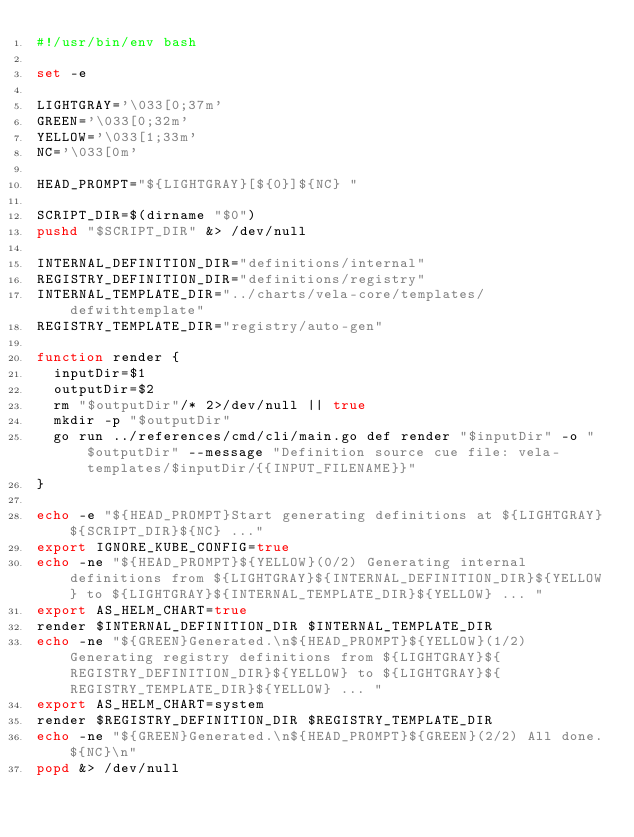Convert code to text. <code><loc_0><loc_0><loc_500><loc_500><_Bash_>#!/usr/bin/env bash

set -e

LIGHTGRAY='\033[0;37m'
GREEN='\033[0;32m'
YELLOW='\033[1;33m'
NC='\033[0m'

HEAD_PROMPT="${LIGHTGRAY}[${0}]${NC} "

SCRIPT_DIR=$(dirname "$0")
pushd "$SCRIPT_DIR" &> /dev/null

INTERNAL_DEFINITION_DIR="definitions/internal"
REGISTRY_DEFINITION_DIR="definitions/registry"
INTERNAL_TEMPLATE_DIR="../charts/vela-core/templates/defwithtemplate"
REGISTRY_TEMPLATE_DIR="registry/auto-gen"

function render {
  inputDir=$1
  outputDir=$2
  rm "$outputDir"/* 2>/dev/null || true
  mkdir -p "$outputDir"
  go run ../references/cmd/cli/main.go def render "$inputDir" -o "$outputDir" --message "Definition source cue file: vela-templates/$inputDir/{{INPUT_FILENAME}}"
}

echo -e "${HEAD_PROMPT}Start generating definitions at ${LIGHTGRAY}${SCRIPT_DIR}${NC} ..."
export IGNORE_KUBE_CONFIG=true
echo -ne "${HEAD_PROMPT}${YELLOW}(0/2) Generating internal definitions from ${LIGHTGRAY}${INTERNAL_DEFINITION_DIR}${YELLOW} to ${LIGHTGRAY}${INTERNAL_TEMPLATE_DIR}${YELLOW} ... "
export AS_HELM_CHART=true
render $INTERNAL_DEFINITION_DIR $INTERNAL_TEMPLATE_DIR
echo -ne "${GREEN}Generated.\n${HEAD_PROMPT}${YELLOW}(1/2) Generating registry definitions from ${LIGHTGRAY}${REGISTRY_DEFINITION_DIR}${YELLOW} to ${LIGHTGRAY}${REGISTRY_TEMPLATE_DIR}${YELLOW} ... "
export AS_HELM_CHART=system
render $REGISTRY_DEFINITION_DIR $REGISTRY_TEMPLATE_DIR
echo -ne "${GREEN}Generated.\n${HEAD_PROMPT}${GREEN}(2/2) All done.${NC}\n"
popd &> /dev/null
</code> 